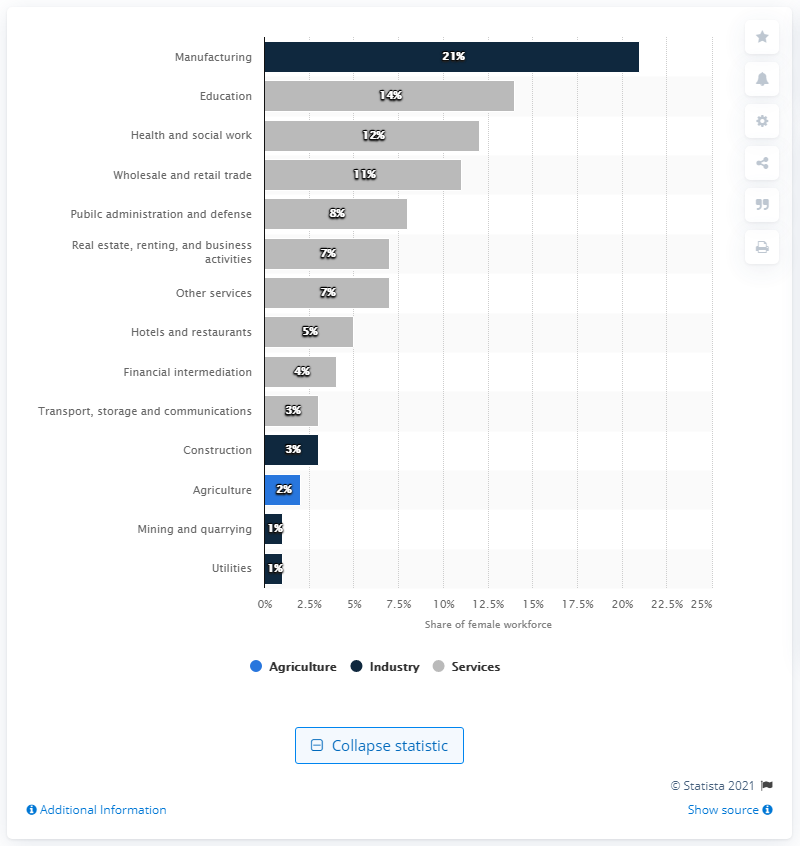Outline some significant characteristics in this image. Manufacturing is the largest employer of female workers, making up the majority of female workers in the industry. 